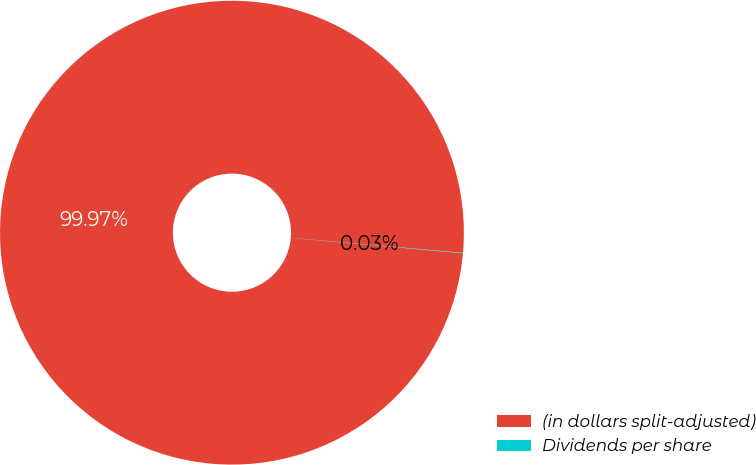<chart> <loc_0><loc_0><loc_500><loc_500><pie_chart><fcel>(in dollars split-adjusted)<fcel>Dividends per share<nl><fcel>99.97%<fcel>0.03%<nl></chart> 